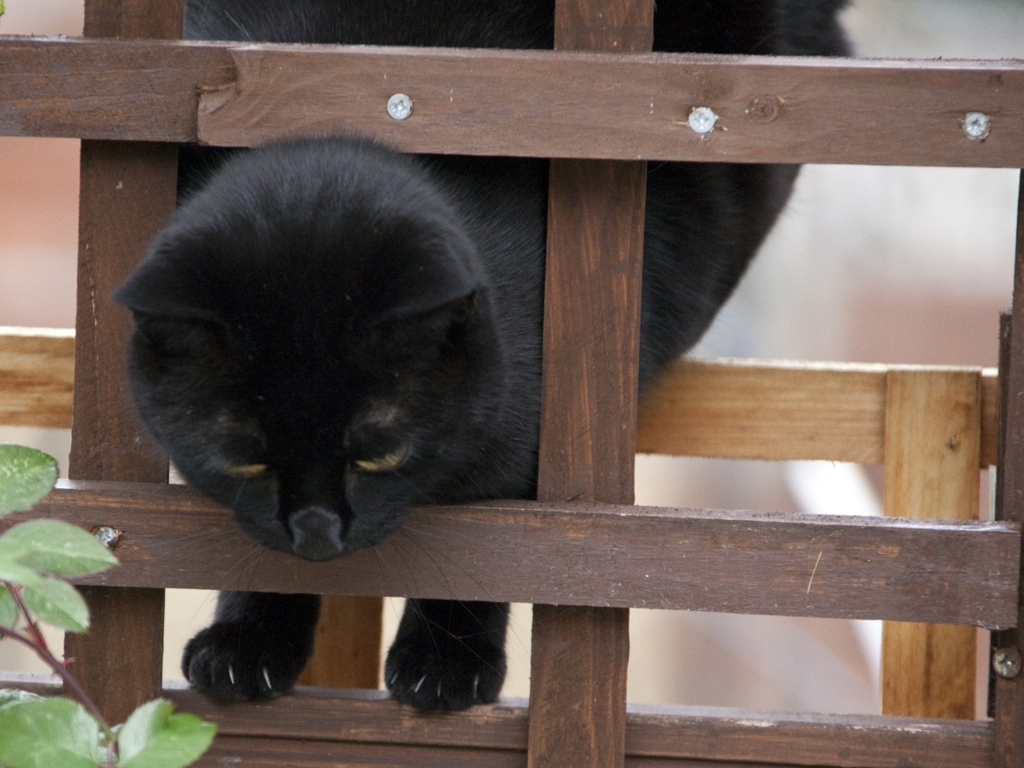What are some photographic improvements that could be made to enhance the visual quality of this picture? To enhance the image, improving lighting conditions would be beneficial to bring out the details in the cat's fur and the textures of the wood. Using a shallower depth of field could create a pleasing bokeh effect and focus the viewer's attention on the cat. Additionally, adjusting the framing to follow the 'rule of thirds' could make the composition more dynamic. Post-processing could also be used to correct the exposure and bring more balance to the light and dark areas of the photo. 